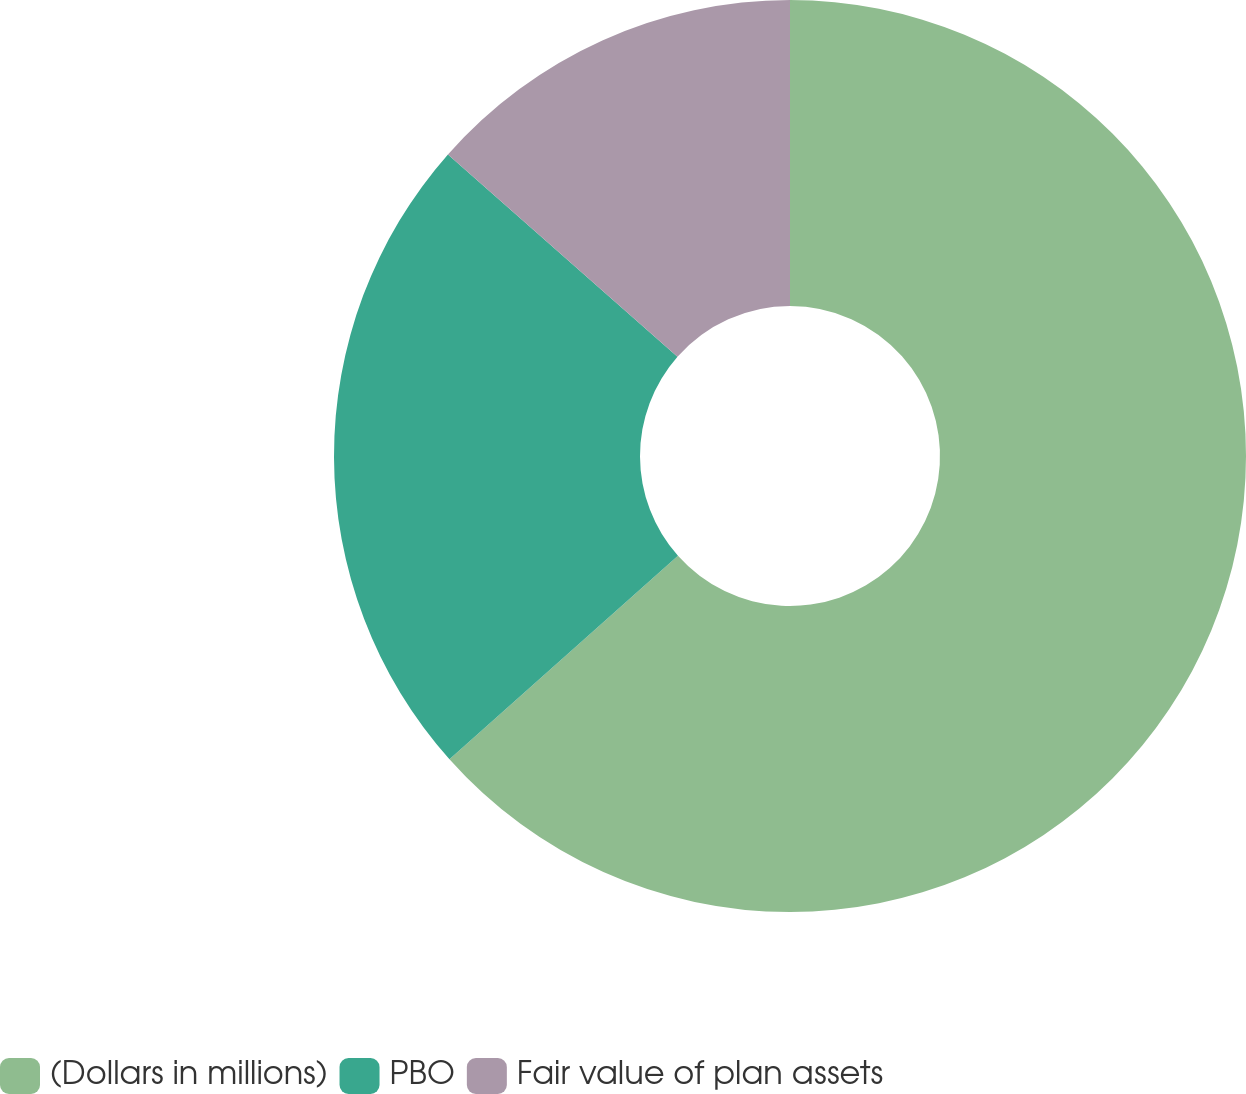<chart> <loc_0><loc_0><loc_500><loc_500><pie_chart><fcel>(Dollars in millions)<fcel>PBO<fcel>Fair value of plan assets<nl><fcel>63.42%<fcel>23.08%<fcel>13.5%<nl></chart> 